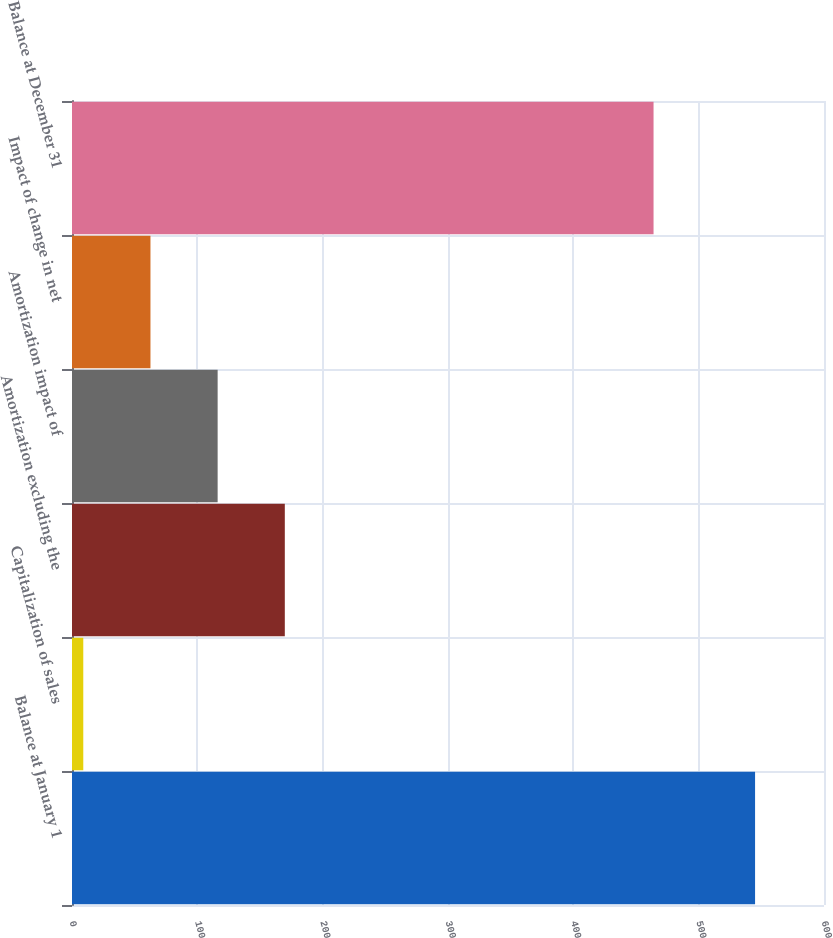<chart> <loc_0><loc_0><loc_500><loc_500><bar_chart><fcel>Balance at January 1<fcel>Capitalization of sales<fcel>Amortization excluding the<fcel>Amortization impact of<fcel>Impact of change in net<fcel>Balance at December 31<nl><fcel>545<fcel>9<fcel>169.8<fcel>116.2<fcel>62.6<fcel>464<nl></chart> 